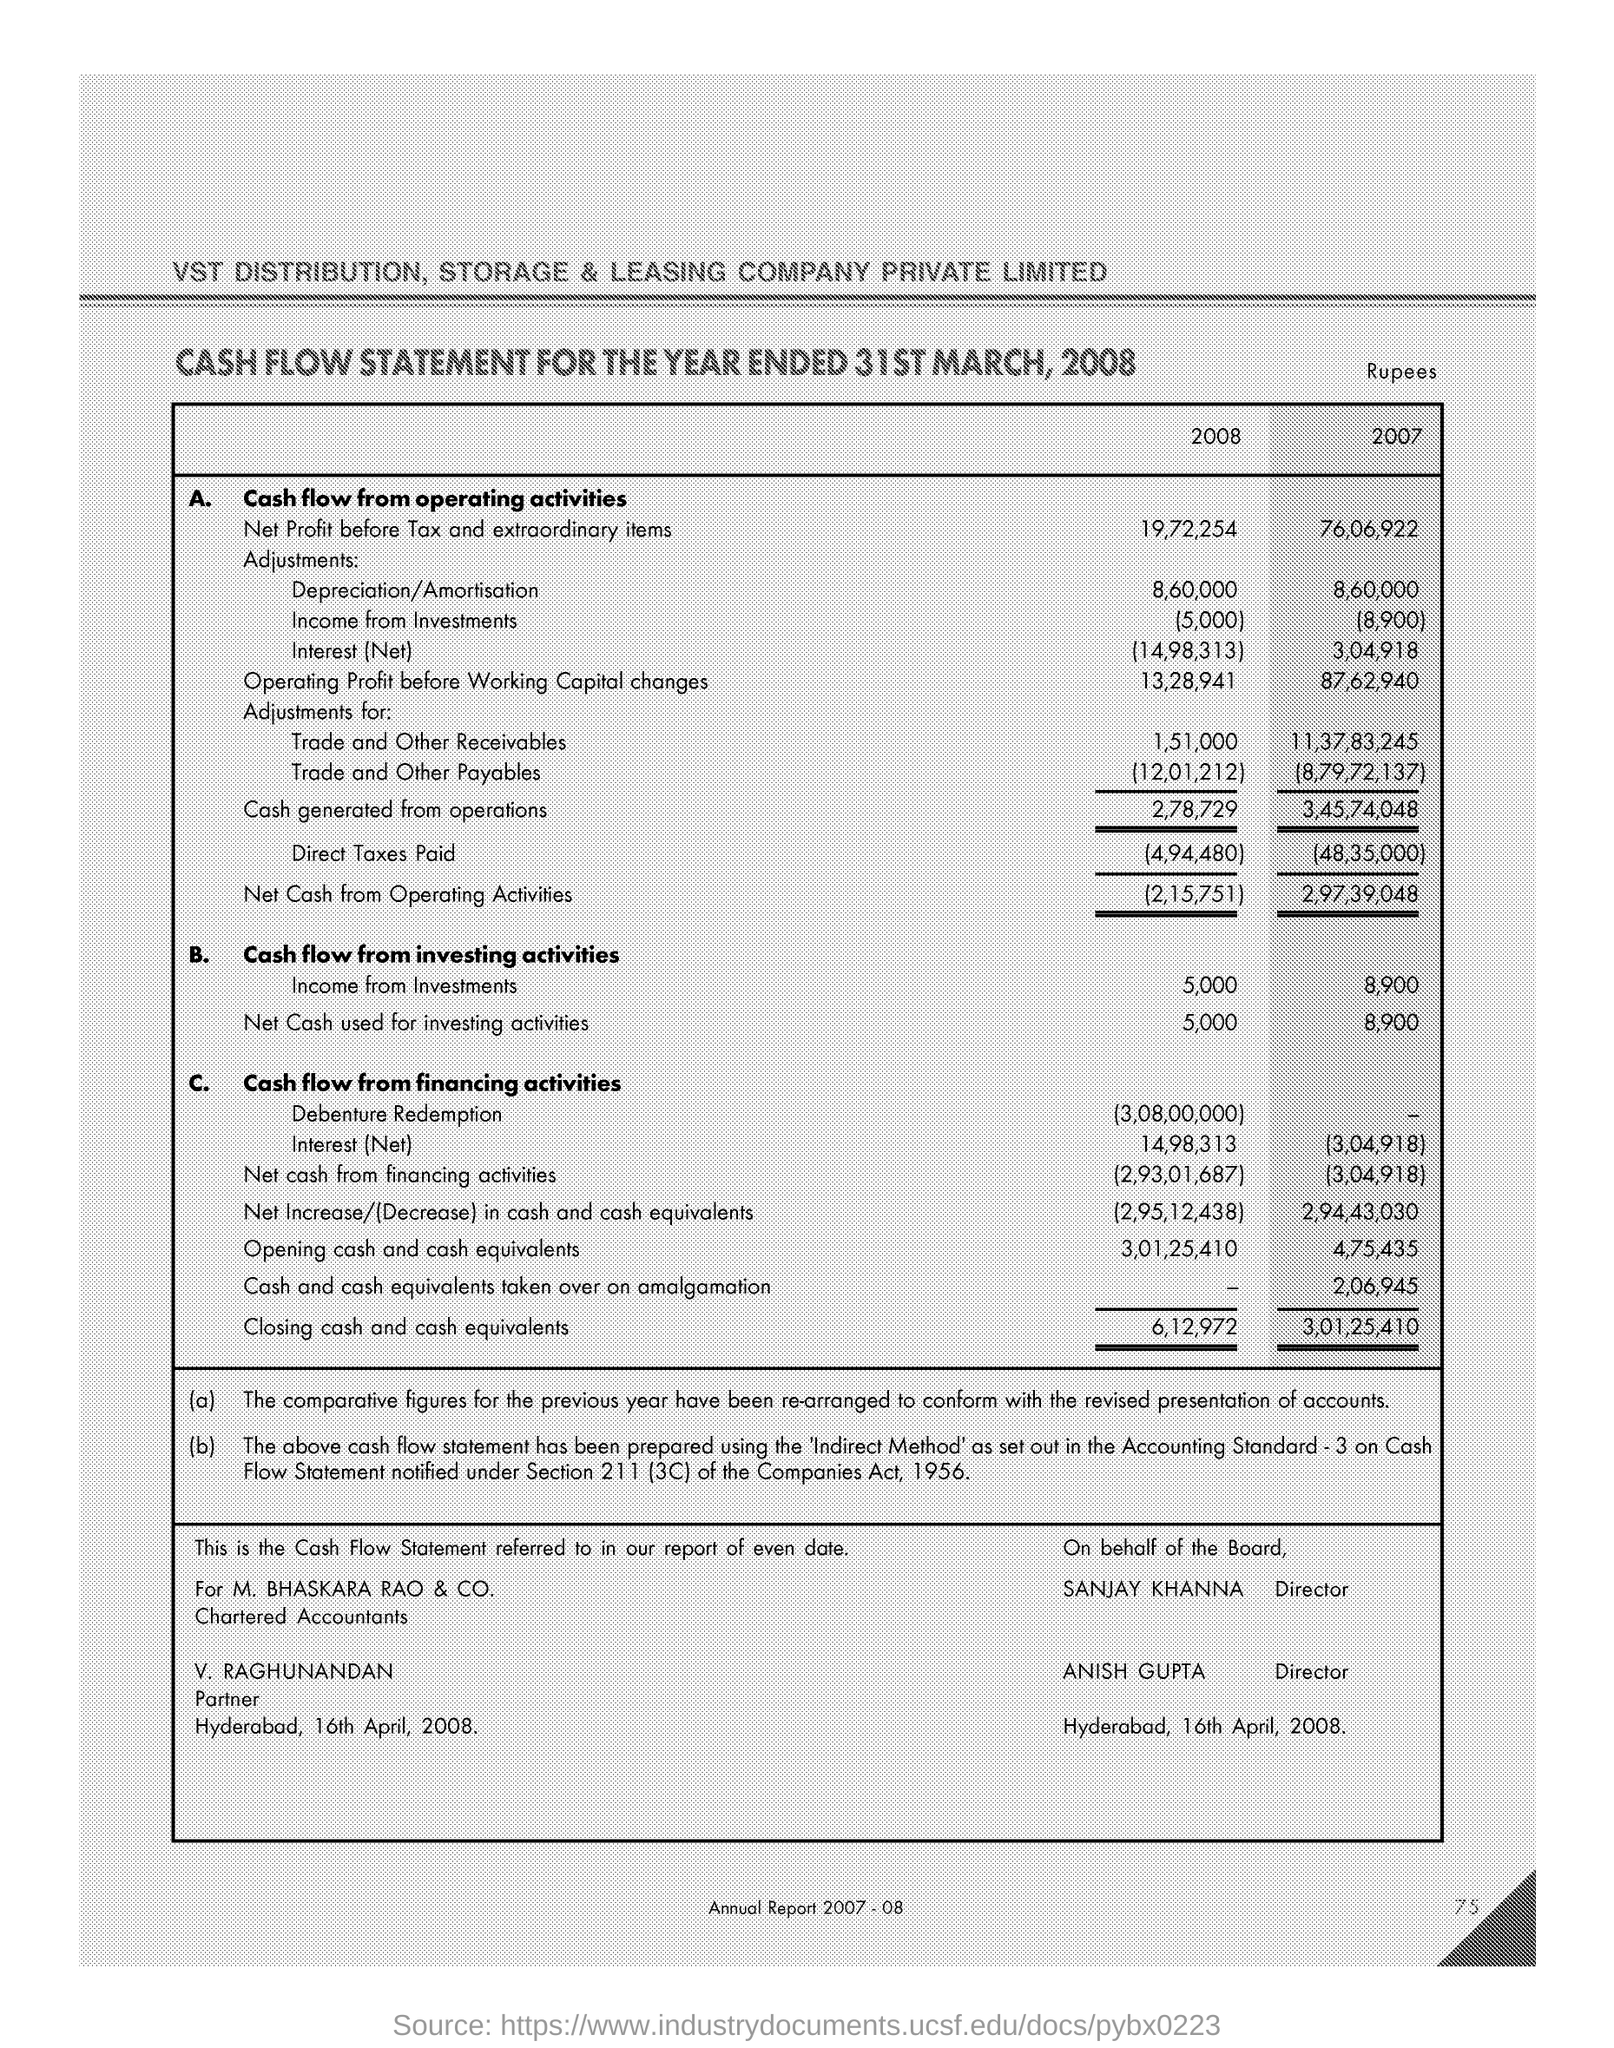How much Net profit before tax and extraordinary items in  the 2007 ?
Give a very brief answer. 76,06,922. 